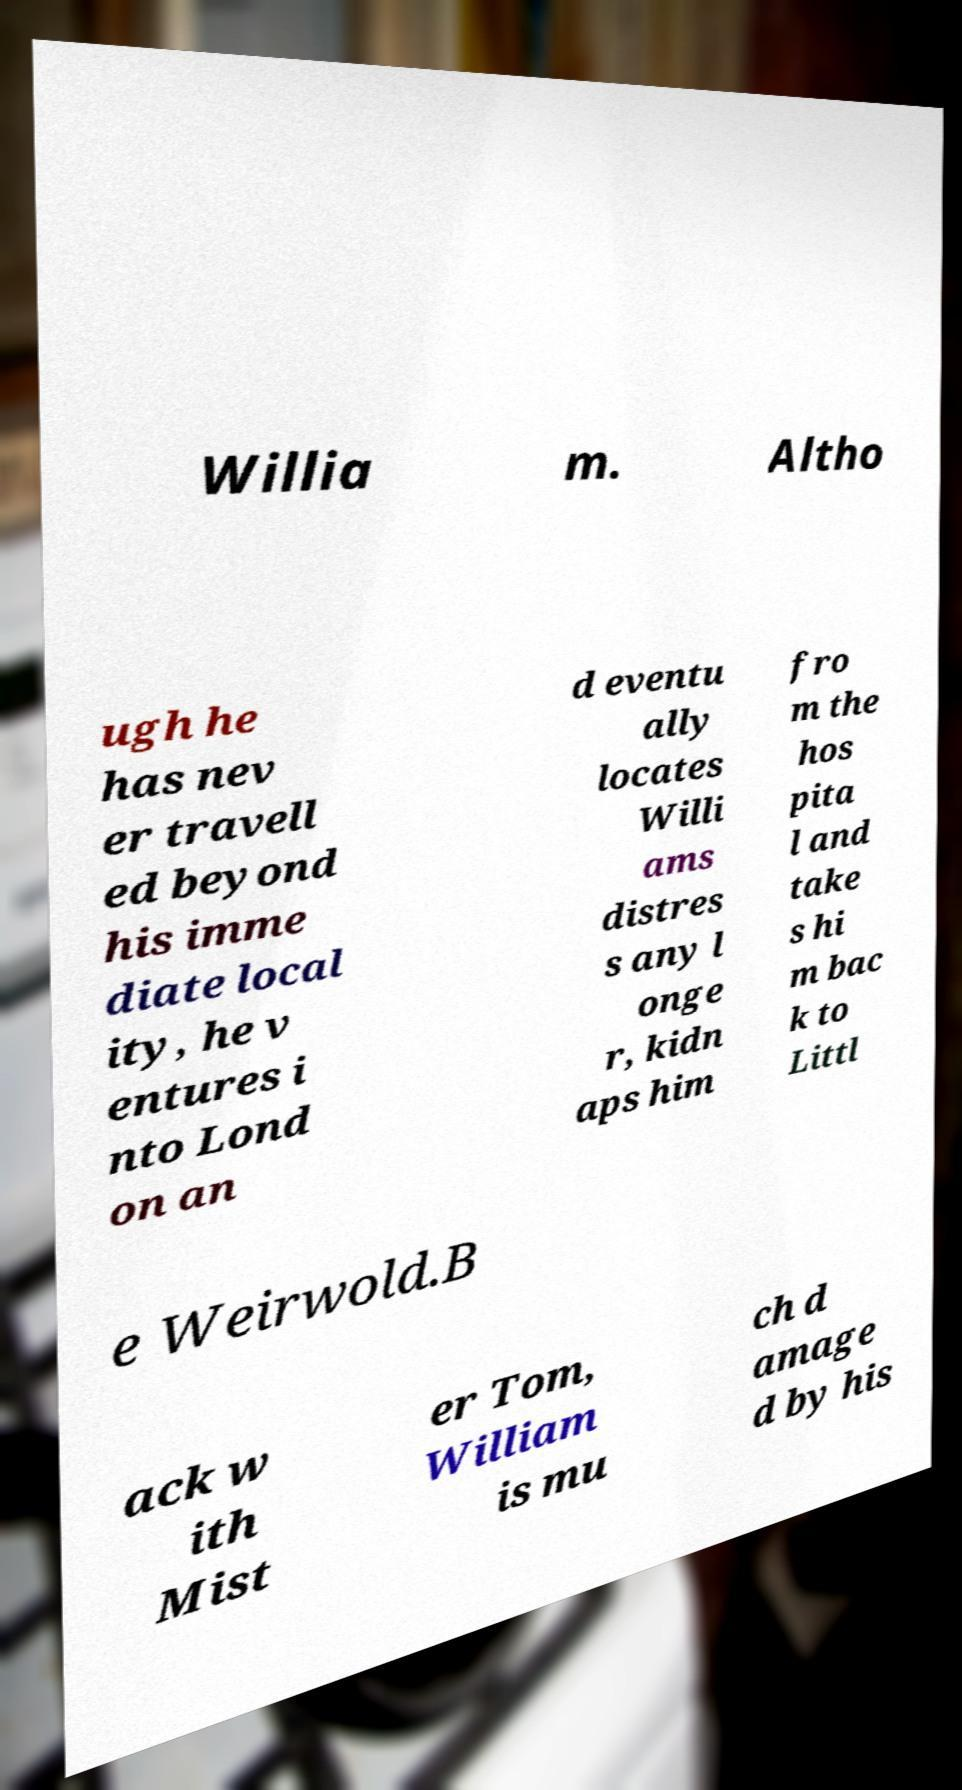There's text embedded in this image that I need extracted. Can you transcribe it verbatim? Willia m. Altho ugh he has nev er travell ed beyond his imme diate local ity, he v entures i nto Lond on an d eventu ally locates Willi ams distres s any l onge r, kidn aps him fro m the hos pita l and take s hi m bac k to Littl e Weirwold.B ack w ith Mist er Tom, William is mu ch d amage d by his 